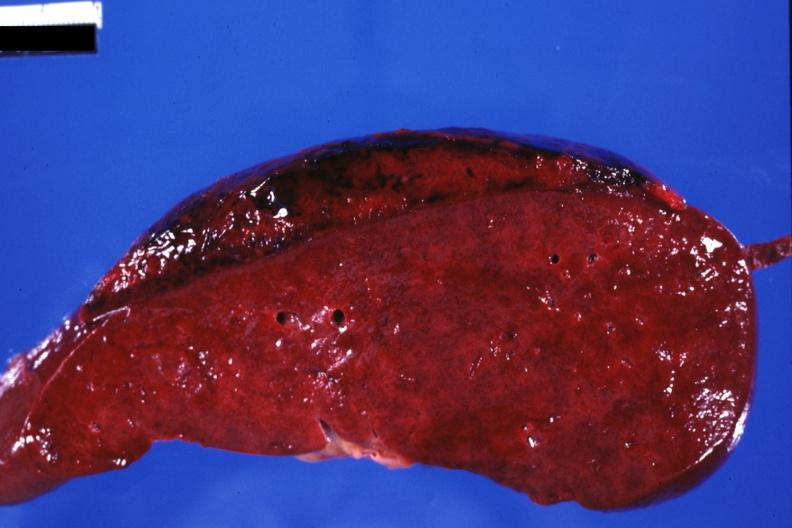s another fiber other frame present?
Answer the question using a single word or phrase. No 